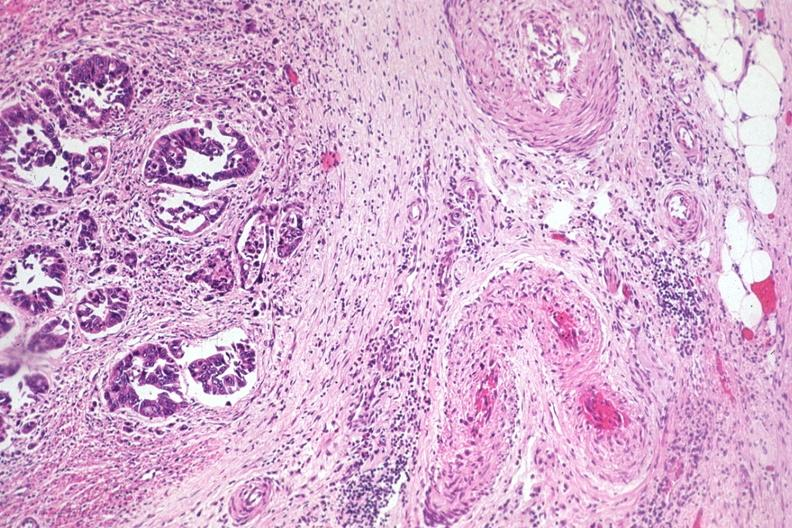what is present?
Answer the question using a single word or phrase. Gastrointestinal 